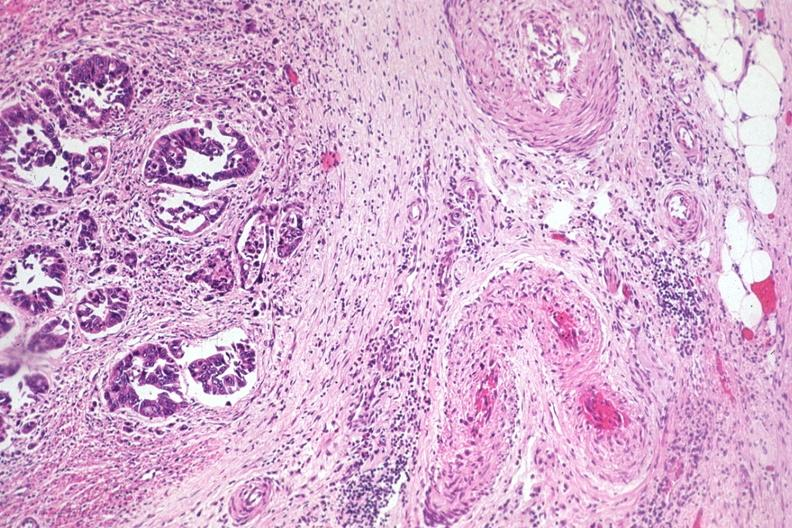what is present?
Answer the question using a single word or phrase. Gastrointestinal 